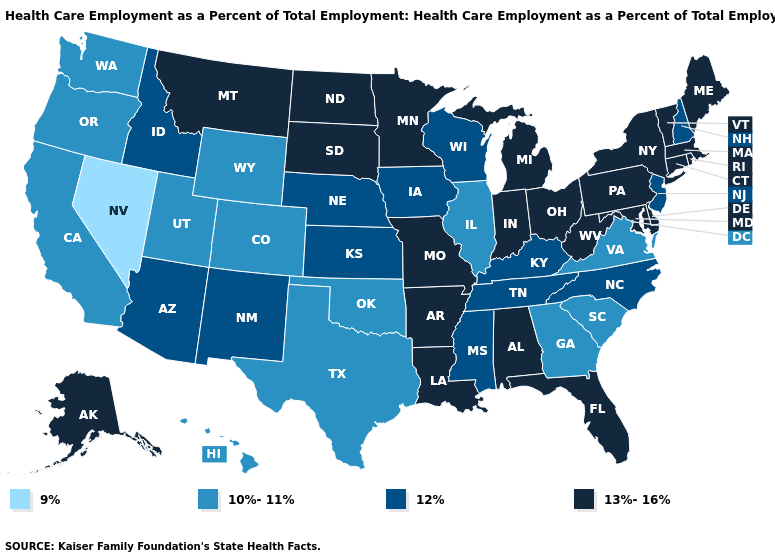Which states have the lowest value in the MidWest?
Short answer required. Illinois. What is the value of New Hampshire?
Quick response, please. 12%. Among the states that border Tennessee , which have the lowest value?
Be succinct. Georgia, Virginia. Does Ohio have the highest value in the USA?
Write a very short answer. Yes. Among the states that border Alabama , does Florida have the highest value?
Quick response, please. Yes. What is the highest value in the South ?
Quick response, please. 13%-16%. Name the states that have a value in the range 12%?
Write a very short answer. Arizona, Idaho, Iowa, Kansas, Kentucky, Mississippi, Nebraska, New Hampshire, New Jersey, New Mexico, North Carolina, Tennessee, Wisconsin. Does the map have missing data?
Short answer required. No. What is the value of Rhode Island?
Keep it brief. 13%-16%. Does North Carolina have the lowest value in the South?
Write a very short answer. No. What is the highest value in the MidWest ?
Be succinct. 13%-16%. What is the value of New Mexico?
Write a very short answer. 12%. What is the value of Maryland?
Short answer required. 13%-16%. What is the value of Rhode Island?
Quick response, please. 13%-16%. Among the states that border Wisconsin , does Illinois have the lowest value?
Quick response, please. Yes. 